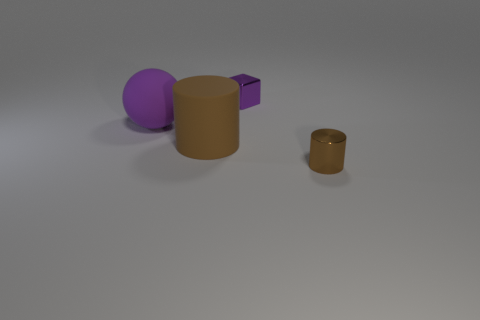How many shiny objects have the same shape as the brown rubber object?
Ensure brevity in your answer.  1. The matte thing that is the same size as the brown rubber cylinder is what color?
Offer a very short reply. Purple. Is the number of brown matte cylinders that are on the right side of the large brown rubber thing the same as the number of tiny brown objects that are left of the purple sphere?
Your answer should be very brief. Yes. Are there any purple metal cylinders of the same size as the brown matte cylinder?
Offer a terse response. No. How big is the sphere?
Offer a terse response. Large. Is the number of rubber objects that are right of the purple shiny block the same as the number of purple metallic objects?
Your answer should be compact. No. What number of other objects are there of the same color as the big matte cylinder?
Keep it short and to the point. 1. There is a thing that is behind the large brown object and on the right side of the large purple sphere; what color is it?
Make the answer very short. Purple. What size is the metallic object in front of the cylinder that is behind the brown object that is right of the small block?
Ensure brevity in your answer.  Small. What number of objects are either shiny objects behind the big brown rubber cylinder or things that are right of the ball?
Keep it short and to the point. 3. 